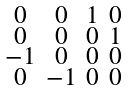Convert formula to latex. <formula><loc_0><loc_0><loc_500><loc_500>\begin{smallmatrix} 0 & 0 & 1 & 0 \\ 0 & 0 & 0 & 1 \\ - 1 & 0 & 0 & 0 \\ 0 & - 1 & 0 & 0 \\ \end{smallmatrix}</formula> 